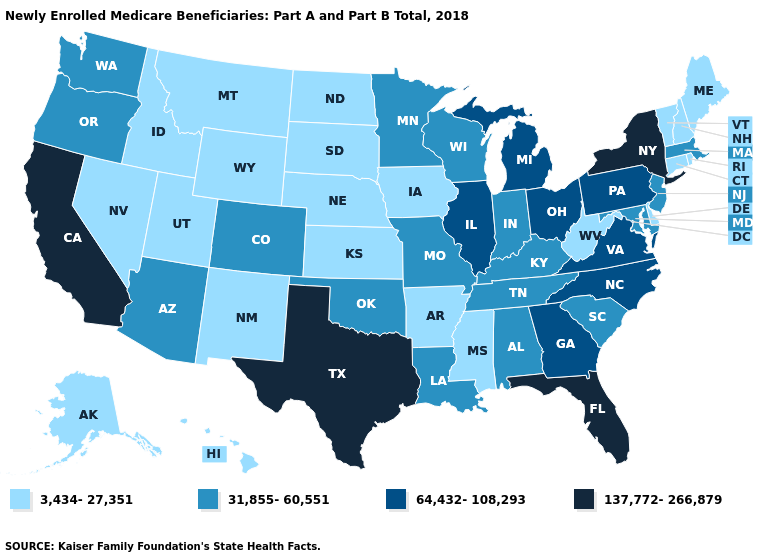What is the value of Missouri?
Be succinct. 31,855-60,551. Does New York have a lower value than Vermont?
Give a very brief answer. No. Name the states that have a value in the range 3,434-27,351?
Quick response, please. Alaska, Arkansas, Connecticut, Delaware, Hawaii, Idaho, Iowa, Kansas, Maine, Mississippi, Montana, Nebraska, Nevada, New Hampshire, New Mexico, North Dakota, Rhode Island, South Dakota, Utah, Vermont, West Virginia, Wyoming. Does the first symbol in the legend represent the smallest category?
Concise answer only. Yes. Does Ohio have the highest value in the MidWest?
Give a very brief answer. Yes. What is the value of Maine?
Concise answer only. 3,434-27,351. Which states have the lowest value in the South?
Keep it brief. Arkansas, Delaware, Mississippi, West Virginia. Which states have the lowest value in the South?
Be succinct. Arkansas, Delaware, Mississippi, West Virginia. Does California have a higher value than Texas?
Give a very brief answer. No. Among the states that border Michigan , which have the highest value?
Write a very short answer. Ohio. Which states have the highest value in the USA?
Quick response, please. California, Florida, New York, Texas. Does the map have missing data?
Give a very brief answer. No. Does the first symbol in the legend represent the smallest category?
Give a very brief answer. Yes. Which states have the lowest value in the USA?
Be succinct. Alaska, Arkansas, Connecticut, Delaware, Hawaii, Idaho, Iowa, Kansas, Maine, Mississippi, Montana, Nebraska, Nevada, New Hampshire, New Mexico, North Dakota, Rhode Island, South Dakota, Utah, Vermont, West Virginia, Wyoming. What is the value of South Dakota?
Answer briefly. 3,434-27,351. 